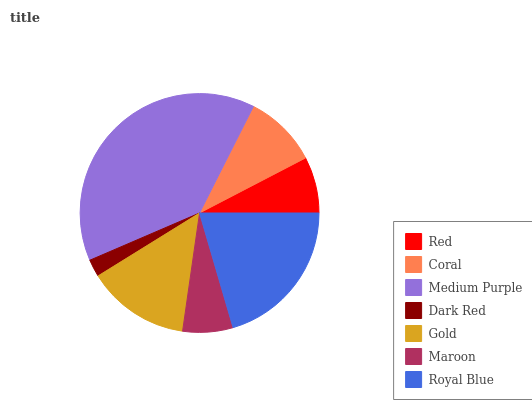Is Dark Red the minimum?
Answer yes or no. Yes. Is Medium Purple the maximum?
Answer yes or no. Yes. Is Coral the minimum?
Answer yes or no. No. Is Coral the maximum?
Answer yes or no. No. Is Coral greater than Red?
Answer yes or no. Yes. Is Red less than Coral?
Answer yes or no. Yes. Is Red greater than Coral?
Answer yes or no. No. Is Coral less than Red?
Answer yes or no. No. Is Coral the high median?
Answer yes or no. Yes. Is Coral the low median?
Answer yes or no. Yes. Is Gold the high median?
Answer yes or no. No. Is Royal Blue the low median?
Answer yes or no. No. 